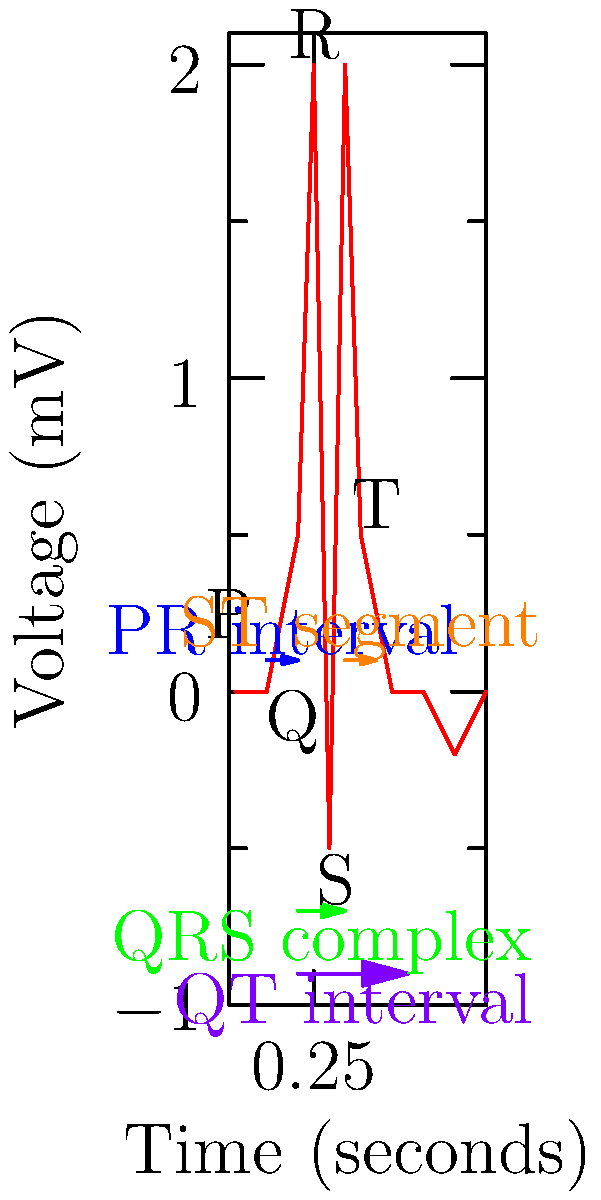In the ECG shown above, which interval represents the total duration of ventricular depolarization and repolarization? To answer this question, we need to understand the different components of an ECG and what they represent:

1. P wave: Represents atrial depolarization
2. QRS complex: Represents ventricular depolarization
3. T wave: Represents ventricular repolarization

The interval that includes both ventricular depolarization and repolarization is the QT interval. Let's break it down:

1. The QT interval starts at the beginning of the Q wave (the start of ventricular depolarization)
2. It includes the entire QRS complex (ventricular depolarization)
3. It also includes the ST segment and T wave (ventricular repolarization)
4. The QT interval ends at the end of the T wave

In the ECG diagram, the QT interval is clearly labeled and marked with a purple arrow. It spans from the beginning of the QRS complex to the end of the T wave, encompassing both ventricular depolarization and repolarization.

The other intervals shown in the diagram do not represent the total duration of both processes:
- PR interval: Represents atrial depolarization and AV node conduction
- QRS complex: Represents only ventricular depolarization
- ST segment: Represents the period between depolarization and repolarization

Therefore, the QT interval is the correct answer as it represents the total duration of ventricular depolarization and repolarization.
Answer: QT interval 